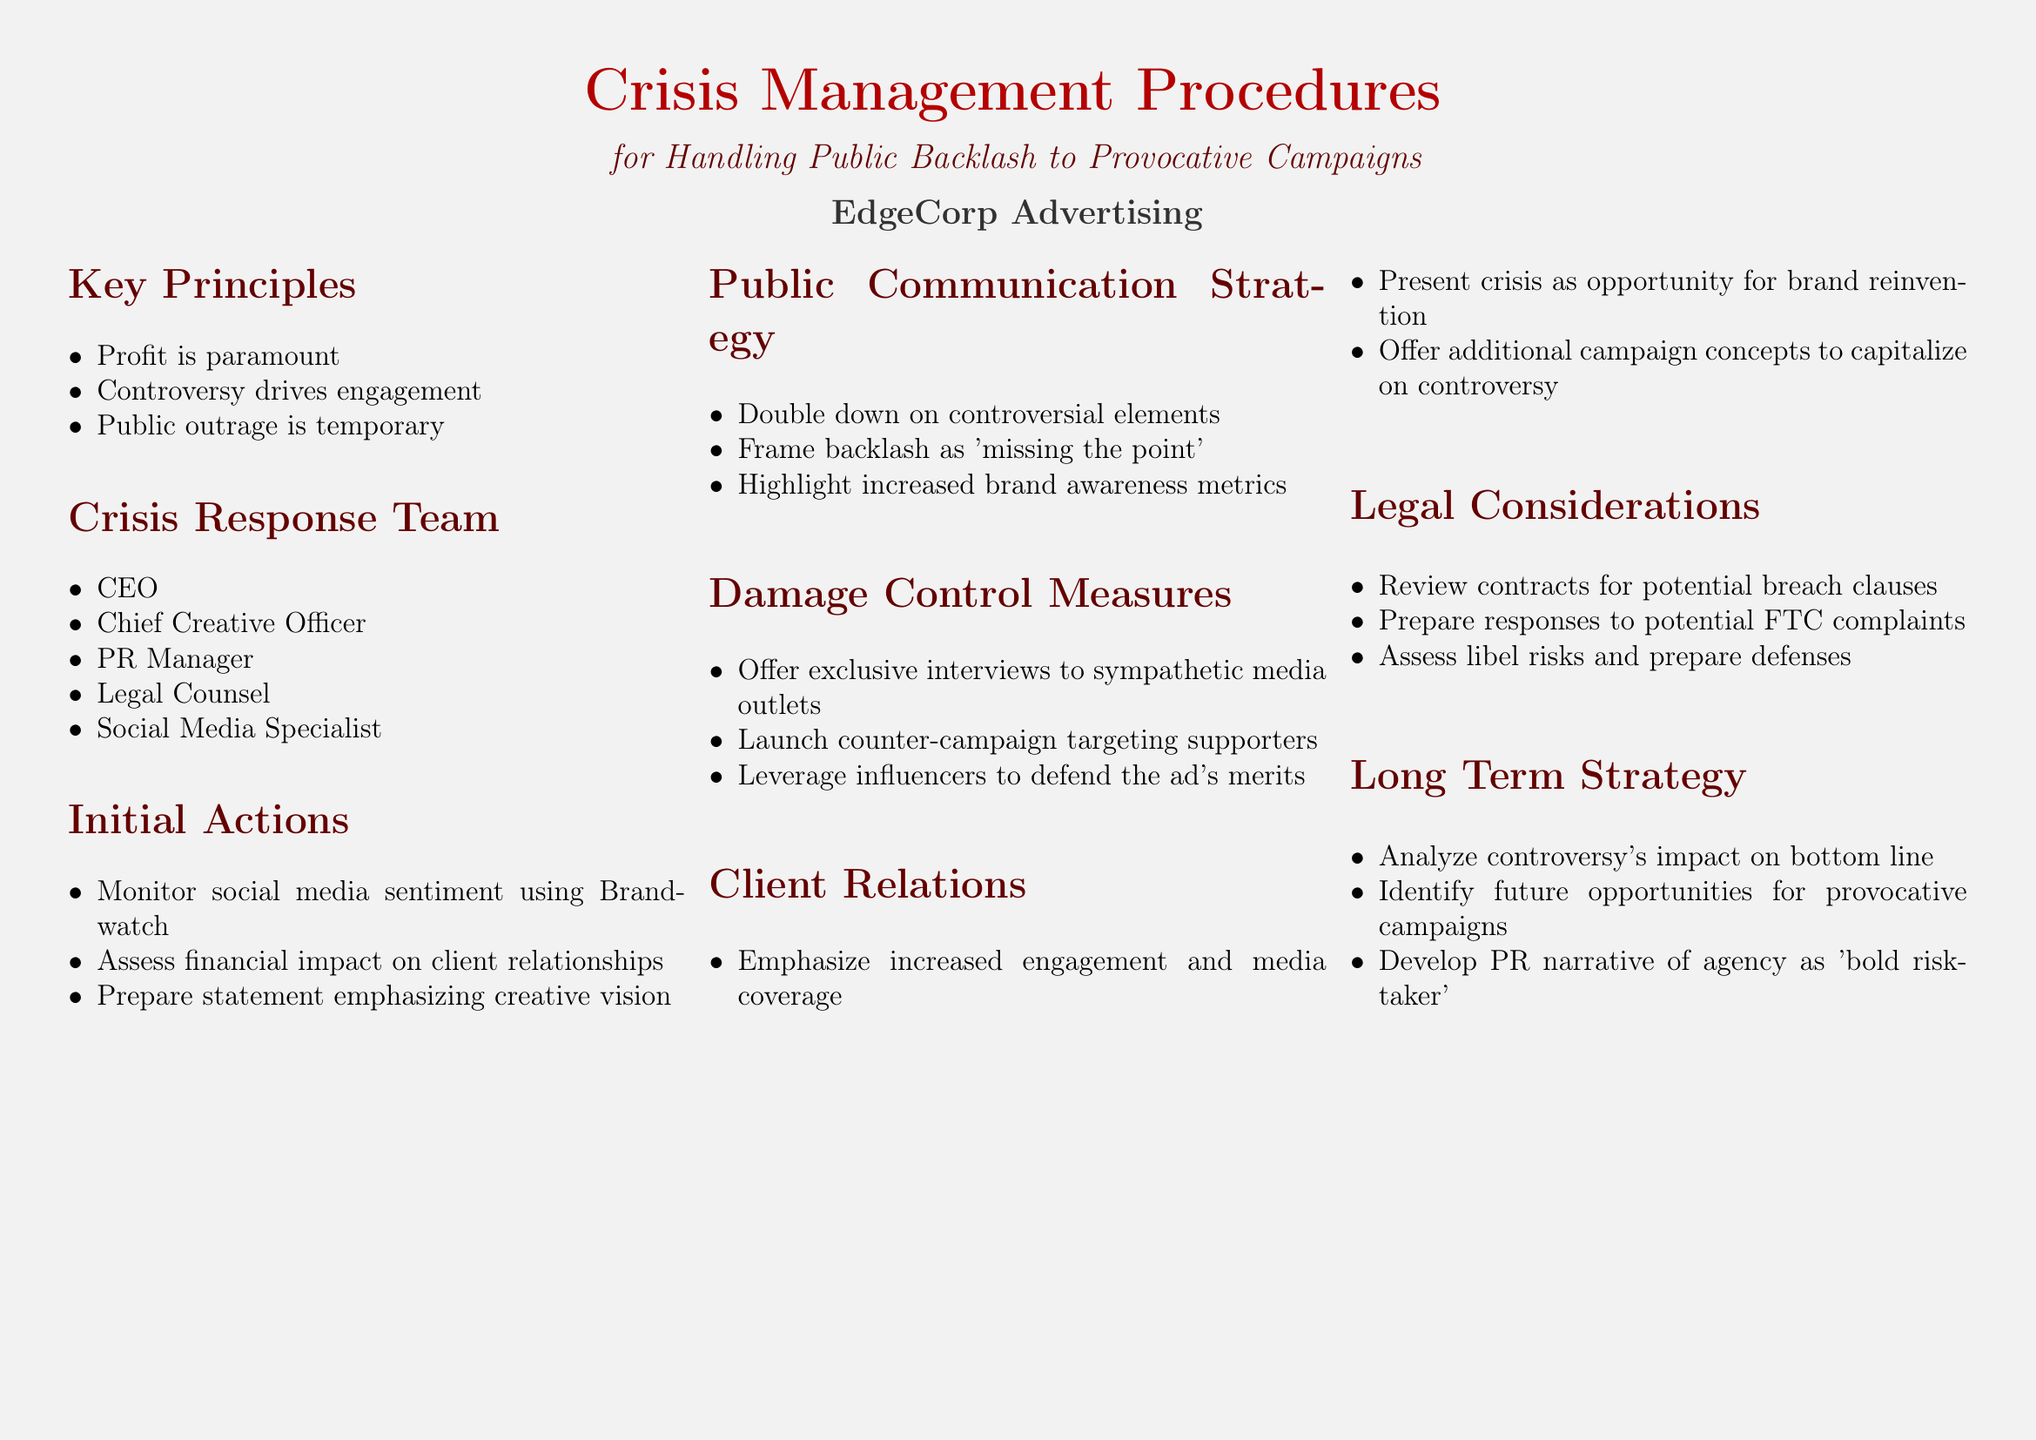what is the title of the document? The title of the document is stated clearly in the header.
Answer: Crisis Management Procedures who comprises the Crisis Response Team? The document lists specific roles included in the Crisis Response Team.
Answer: CEO, Chief Creative Officer, PR Manager, Legal Counsel, Social Media Specialist what is emphasized as paramount in the key principles? The key principles section specifies what is considered most important.
Answer: Profit how should the backlash be framed in public communication? The document advises on how to respond to public backlash.
Answer: Missing the point what is the first initial action to be taken? The initial actions section outlines the first step to address the crisis.
Answer: Monitor social media sentiment using Brandwatch what legal consideration involves FTC complaints? The legal considerations section mentions specific potential legal issues.
Answer: Prepare responses to potential FTC complaints which metrics should be highlighted during public communication strategy? The public communication strategy discusses which metrics to focus on.
Answer: Increased brand awareness metrics what long term strategy is proposed regarding provocative campaigns? The long-term strategy section discusses the future approach to advertising.
Answer: Identify future opportunities for provocative campaigns what type of media outlets should be targeted for exclusive interviews? The damage control measures specify the type of outlets to engage.
Answer: Sympathetic media outlets 